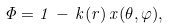<formula> <loc_0><loc_0><loc_500><loc_500>\Phi = 1 \, - \, k ( r ) \, x ( \theta , \varphi ) ,</formula> 